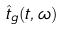<formula> <loc_0><loc_0><loc_500><loc_500>\hat { t } _ { g } ( t , \omega )</formula> 